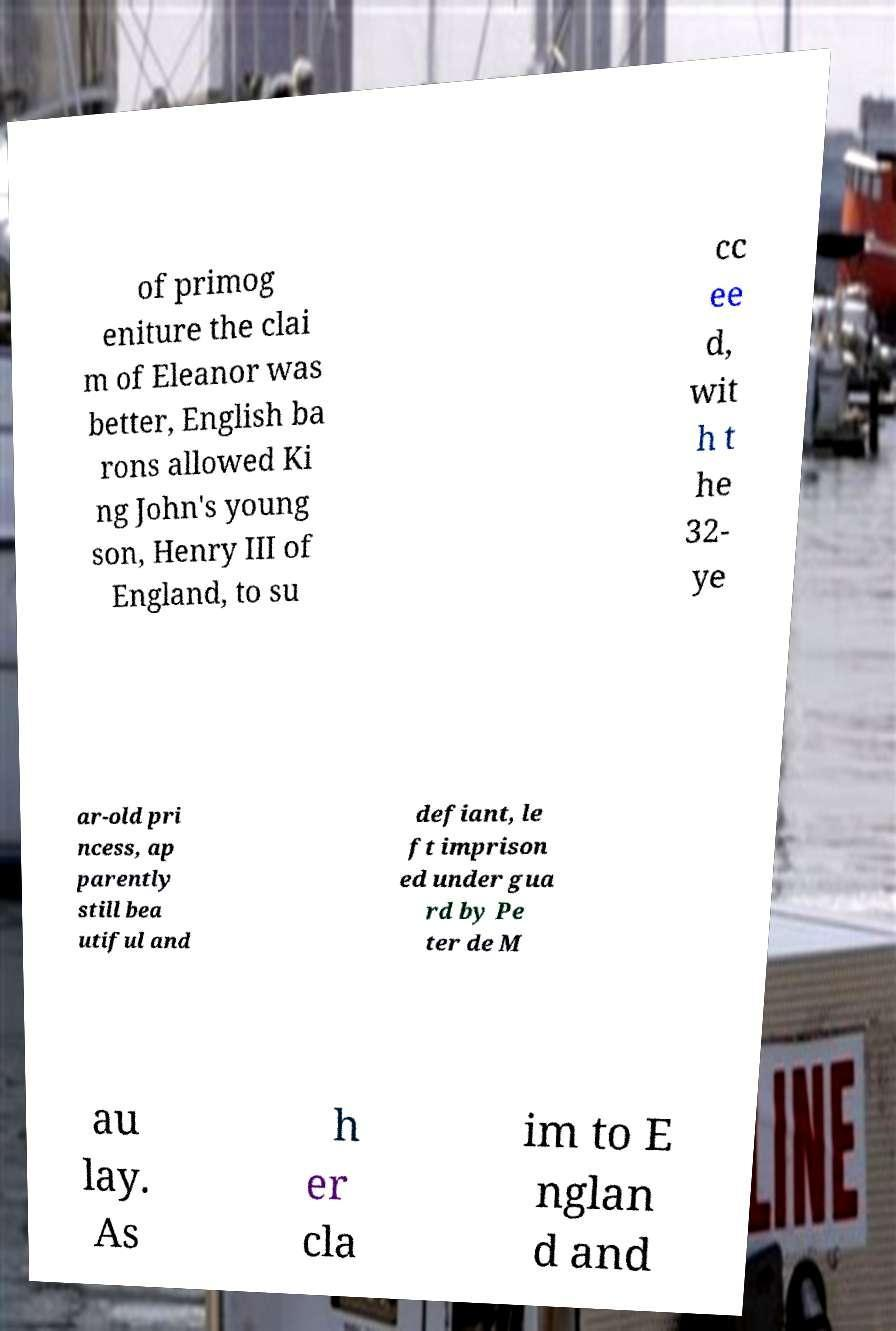For documentation purposes, I need the text within this image transcribed. Could you provide that? of primog eniture the clai m of Eleanor was better, English ba rons allowed Ki ng John's young son, Henry III of England, to su cc ee d, wit h t he 32- ye ar-old pri ncess, ap parently still bea utiful and defiant, le ft imprison ed under gua rd by Pe ter de M au lay. As h er cla im to E nglan d and 